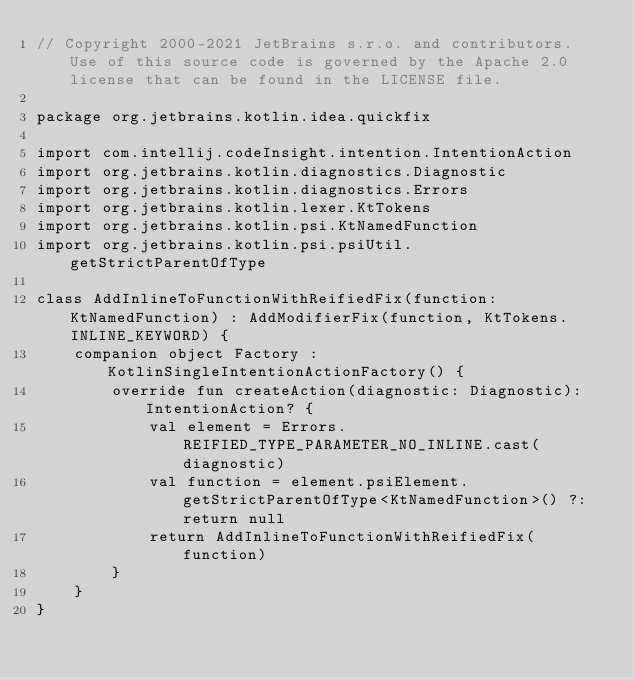<code> <loc_0><loc_0><loc_500><loc_500><_Kotlin_>// Copyright 2000-2021 JetBrains s.r.o. and contributors. Use of this source code is governed by the Apache 2.0 license that can be found in the LICENSE file.

package org.jetbrains.kotlin.idea.quickfix

import com.intellij.codeInsight.intention.IntentionAction
import org.jetbrains.kotlin.diagnostics.Diagnostic
import org.jetbrains.kotlin.diagnostics.Errors
import org.jetbrains.kotlin.lexer.KtTokens
import org.jetbrains.kotlin.psi.KtNamedFunction
import org.jetbrains.kotlin.psi.psiUtil.getStrictParentOfType

class AddInlineToFunctionWithReifiedFix(function: KtNamedFunction) : AddModifierFix(function, KtTokens.INLINE_KEYWORD) {
    companion object Factory : KotlinSingleIntentionActionFactory() {
        override fun createAction(diagnostic: Diagnostic): IntentionAction? {
            val element = Errors.REIFIED_TYPE_PARAMETER_NO_INLINE.cast(diagnostic)
            val function = element.psiElement.getStrictParentOfType<KtNamedFunction>() ?: return null
            return AddInlineToFunctionWithReifiedFix(function)
        }
    }
}</code> 